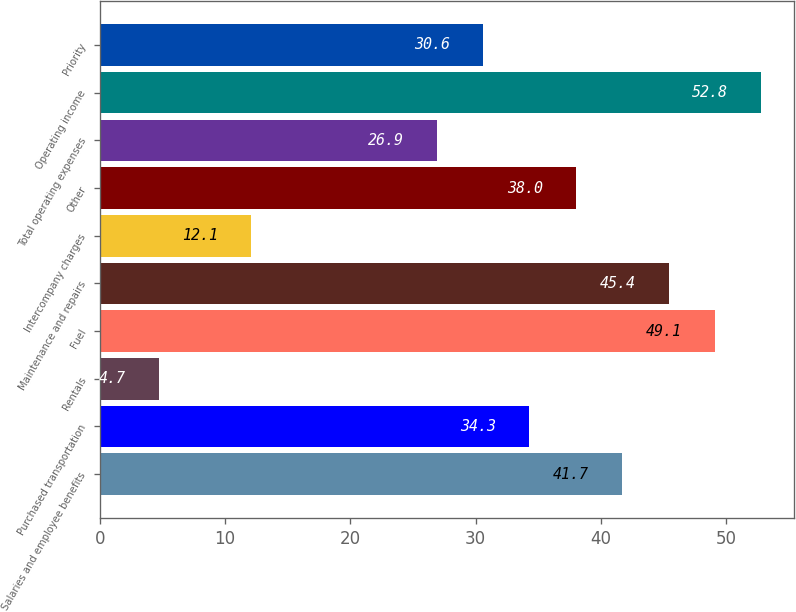<chart> <loc_0><loc_0><loc_500><loc_500><bar_chart><fcel>Salaries and employee benefits<fcel>Purchased transportation<fcel>Rentals<fcel>Fuel<fcel>Maintenance and repairs<fcel>Intercompany charges<fcel>Other<fcel>Total operating expenses<fcel>Operating income<fcel>Priority<nl><fcel>41.7<fcel>34.3<fcel>4.7<fcel>49.1<fcel>45.4<fcel>12.1<fcel>38<fcel>26.9<fcel>52.8<fcel>30.6<nl></chart> 